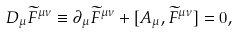<formula> <loc_0><loc_0><loc_500><loc_500>D _ { \mu } \widetilde { F } ^ { \mu \nu } \equiv \partial _ { \mu } \widetilde { F } ^ { \mu \nu } + [ A _ { \mu } , \widetilde { F } ^ { \mu \nu } ] = 0 ,</formula> 